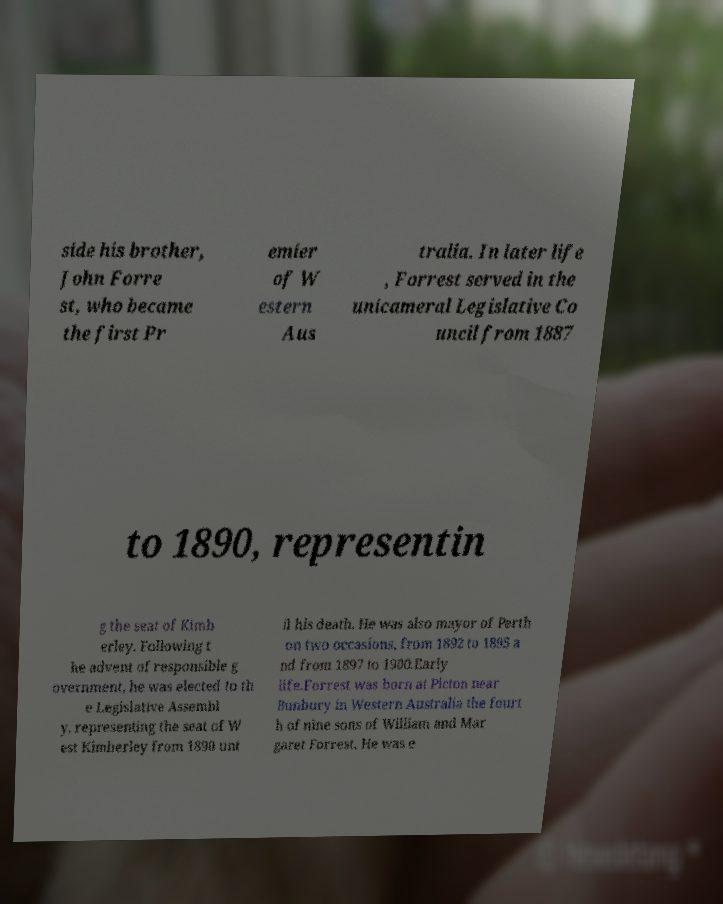What messages or text are displayed in this image? I need them in a readable, typed format. side his brother, John Forre st, who became the first Pr emier of W estern Aus tralia. In later life , Forrest served in the unicameral Legislative Co uncil from 1887 to 1890, representin g the seat of Kimb erley. Following t he advent of responsible g overnment, he was elected to th e Legislative Assembl y, representing the seat of W est Kimberley from 1890 unt il his death. He was also mayor of Perth on two occasions, from 1892 to 1895 a nd from 1897 to 1900.Early life.Forrest was born at Picton near Bunbury in Western Australia the fourt h of nine sons of William and Mar garet Forrest. He was e 